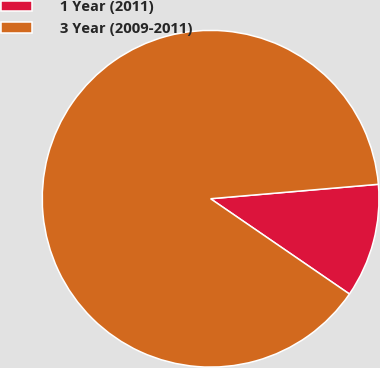<chart> <loc_0><loc_0><loc_500><loc_500><pie_chart><fcel>1 Year (2011)<fcel>3 Year (2009-2011)<nl><fcel>10.94%<fcel>89.06%<nl></chart> 